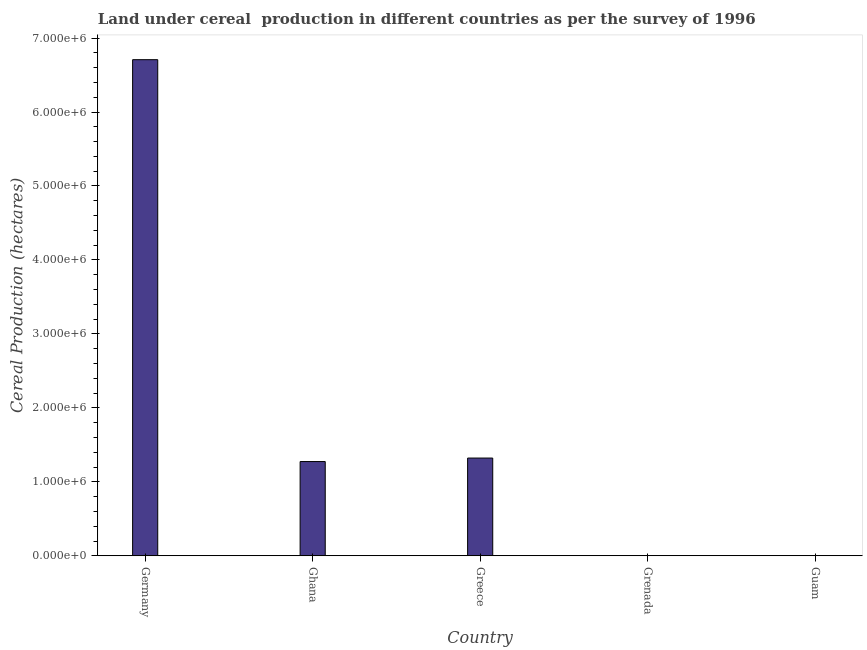Does the graph contain any zero values?
Your answer should be very brief. No. What is the title of the graph?
Your response must be concise. Land under cereal  production in different countries as per the survey of 1996. What is the label or title of the Y-axis?
Your response must be concise. Cereal Production (hectares). What is the land under cereal production in Grenada?
Keep it short and to the point. 330. Across all countries, what is the maximum land under cereal production?
Provide a short and direct response. 6.71e+06. In which country was the land under cereal production maximum?
Provide a succinct answer. Germany. In which country was the land under cereal production minimum?
Your response must be concise. Guam. What is the sum of the land under cereal production?
Give a very brief answer. 9.30e+06. What is the difference between the land under cereal production in Grenada and Guam?
Your answer should be compact. 318. What is the average land under cereal production per country?
Give a very brief answer. 1.86e+06. What is the median land under cereal production?
Provide a short and direct response. 1.27e+06. What is the ratio of the land under cereal production in Ghana to that in Guam?
Ensure brevity in your answer.  1.06e+05. Is the land under cereal production in Germany less than that in Ghana?
Provide a short and direct response. No. What is the difference between the highest and the second highest land under cereal production?
Provide a short and direct response. 5.39e+06. What is the difference between the highest and the lowest land under cereal production?
Your response must be concise. 6.71e+06. In how many countries, is the land under cereal production greater than the average land under cereal production taken over all countries?
Make the answer very short. 1. How many countries are there in the graph?
Provide a succinct answer. 5. What is the difference between two consecutive major ticks on the Y-axis?
Give a very brief answer. 1.00e+06. What is the Cereal Production (hectares) of Germany?
Offer a very short reply. 6.71e+06. What is the Cereal Production (hectares) of Ghana?
Your answer should be very brief. 1.27e+06. What is the Cereal Production (hectares) in Greece?
Your response must be concise. 1.32e+06. What is the Cereal Production (hectares) in Grenada?
Your answer should be very brief. 330. What is the difference between the Cereal Production (hectares) in Germany and Ghana?
Your answer should be compact. 5.43e+06. What is the difference between the Cereal Production (hectares) in Germany and Greece?
Ensure brevity in your answer.  5.39e+06. What is the difference between the Cereal Production (hectares) in Germany and Grenada?
Your response must be concise. 6.71e+06. What is the difference between the Cereal Production (hectares) in Germany and Guam?
Provide a succinct answer. 6.71e+06. What is the difference between the Cereal Production (hectares) in Ghana and Greece?
Your answer should be very brief. -4.72e+04. What is the difference between the Cereal Production (hectares) in Ghana and Grenada?
Offer a terse response. 1.27e+06. What is the difference between the Cereal Production (hectares) in Ghana and Guam?
Ensure brevity in your answer.  1.27e+06. What is the difference between the Cereal Production (hectares) in Greece and Grenada?
Keep it short and to the point. 1.32e+06. What is the difference between the Cereal Production (hectares) in Greece and Guam?
Ensure brevity in your answer.  1.32e+06. What is the difference between the Cereal Production (hectares) in Grenada and Guam?
Make the answer very short. 318. What is the ratio of the Cereal Production (hectares) in Germany to that in Ghana?
Ensure brevity in your answer.  5.26. What is the ratio of the Cereal Production (hectares) in Germany to that in Greece?
Offer a very short reply. 5.08. What is the ratio of the Cereal Production (hectares) in Germany to that in Grenada?
Ensure brevity in your answer.  2.03e+04. What is the ratio of the Cereal Production (hectares) in Germany to that in Guam?
Your answer should be very brief. 5.59e+05. What is the ratio of the Cereal Production (hectares) in Ghana to that in Greece?
Give a very brief answer. 0.96. What is the ratio of the Cereal Production (hectares) in Ghana to that in Grenada?
Make the answer very short. 3861. What is the ratio of the Cereal Production (hectares) in Ghana to that in Guam?
Provide a short and direct response. 1.06e+05. What is the ratio of the Cereal Production (hectares) in Greece to that in Grenada?
Your answer should be compact. 4004.13. What is the ratio of the Cereal Production (hectares) in Greece to that in Guam?
Offer a very short reply. 1.10e+05. 